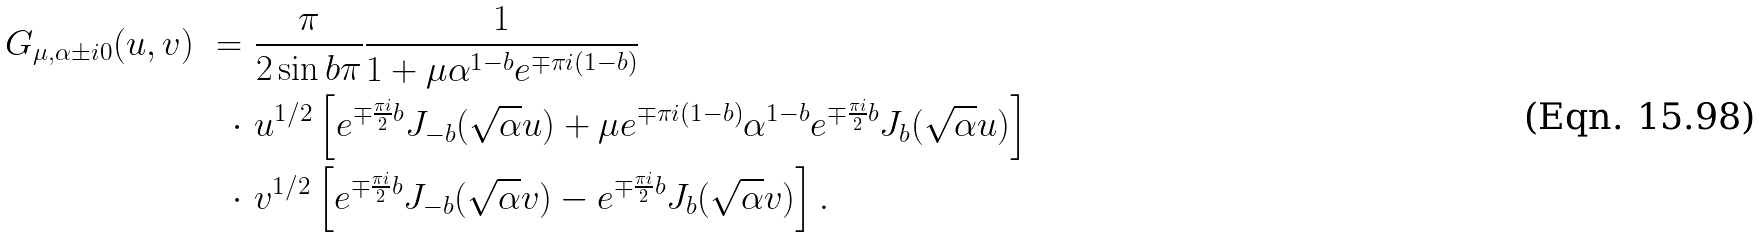<formula> <loc_0><loc_0><loc_500><loc_500>G _ { \mu , \alpha \pm i 0 } ( u , v ) \ = \ & \frac { \pi } { 2 \sin b \pi } \frac { 1 } { 1 + \mu \alpha ^ { 1 - b } e ^ { \mp \pi i ( 1 - b ) } } \\ \cdot \ & u ^ { 1 / 2 } \left [ e ^ { \mp \frac { \pi i } { 2 } b } J _ { - b } ( \sqrt { \alpha } u ) + \mu e ^ { \mp \pi i ( 1 - b ) } \alpha ^ { 1 - b } e ^ { \mp \frac { \pi i } { 2 } b } J _ { b } ( \sqrt { \alpha } u ) \right ] \\ \cdot \ & v ^ { 1 / 2 } \left [ e ^ { \mp \frac { \pi i } { 2 } b } J _ { - b } ( \sqrt { \alpha } v ) - e ^ { \mp \frac { \pi i } { 2 } b } J _ { b } ( \sqrt { \alpha } v ) \right ] .</formula> 